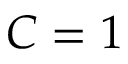<formula> <loc_0><loc_0><loc_500><loc_500>C = 1</formula> 